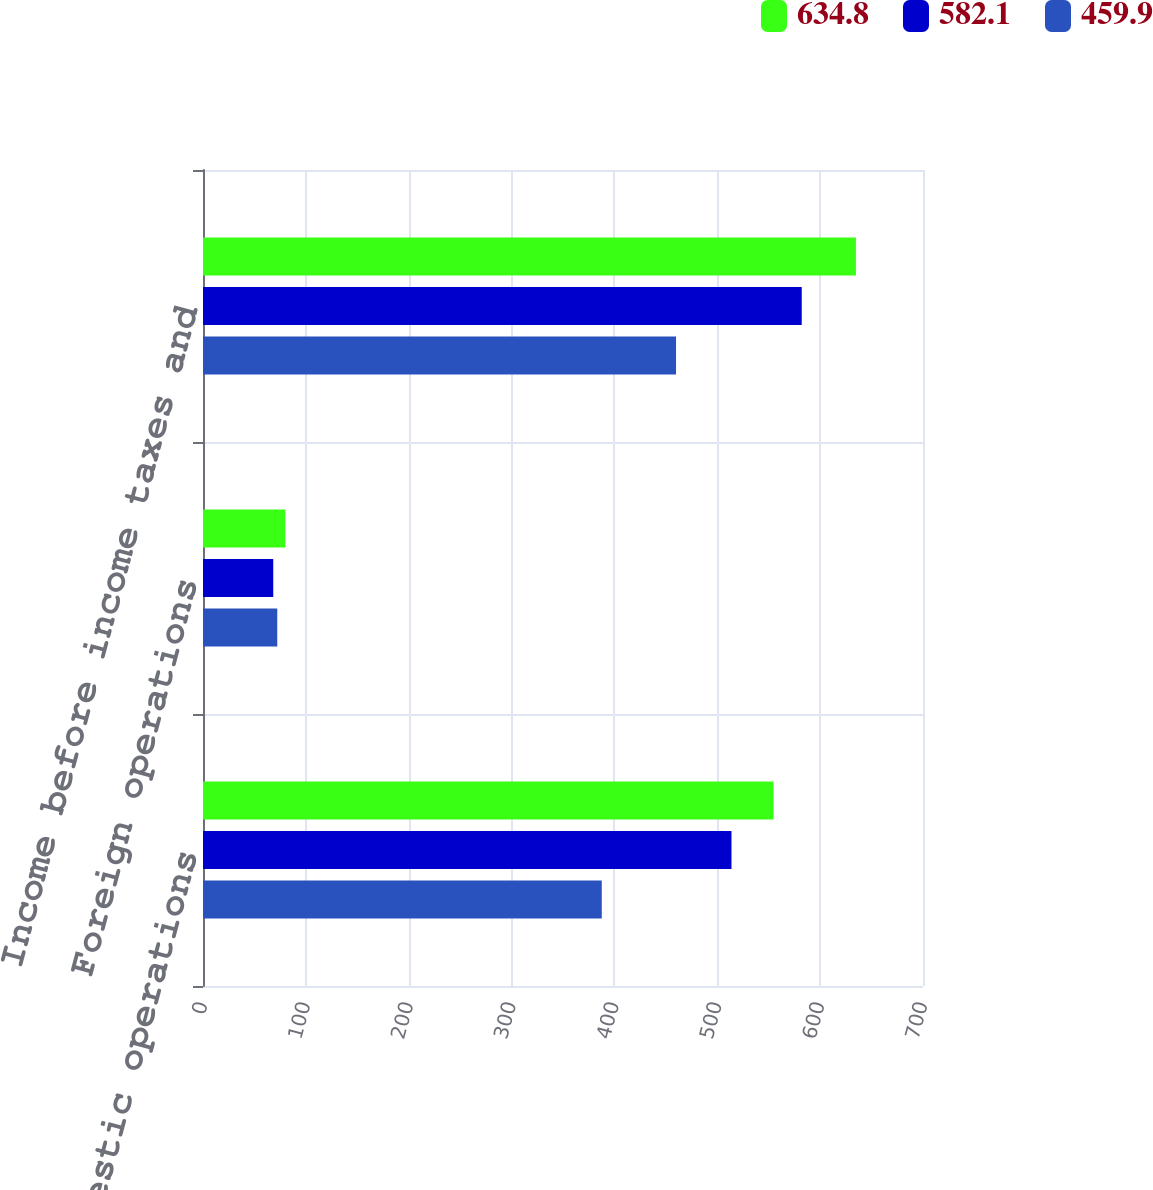<chart> <loc_0><loc_0><loc_500><loc_500><stacked_bar_chart><ecel><fcel>Domestic operations<fcel>Foreign operations<fcel>Income before income taxes and<nl><fcel>634.8<fcel>554.7<fcel>80.1<fcel>634.8<nl><fcel>582.1<fcel>513.8<fcel>68.3<fcel>582.1<nl><fcel>459.9<fcel>387.7<fcel>72.2<fcel>459.9<nl></chart> 